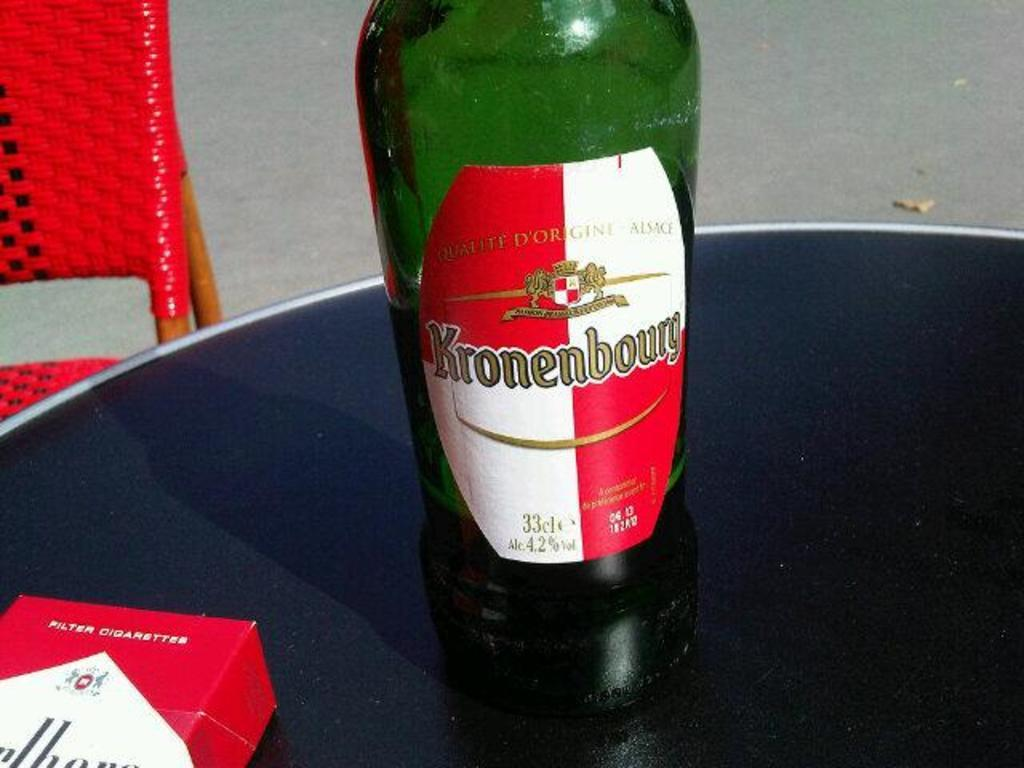Provide a one-sentence caption for the provided image. A half full green bottle with a red and white label of Kronenbourg. 